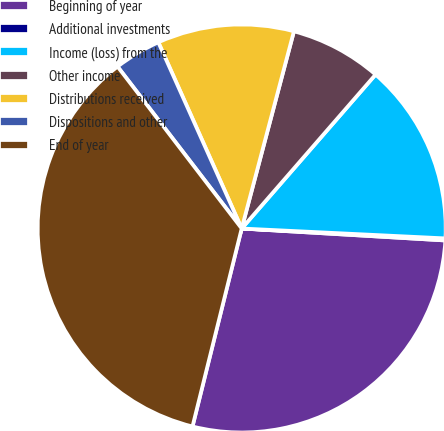<chart> <loc_0><loc_0><loc_500><loc_500><pie_chart><fcel>Beginning of year<fcel>Additional investments<fcel>Income (loss) from the<fcel>Other income<fcel>Distributions received<fcel>Dispositions and other<fcel>End of year<nl><fcel>27.94%<fcel>0.16%<fcel>14.38%<fcel>7.27%<fcel>10.82%<fcel>3.71%<fcel>35.71%<nl></chart> 